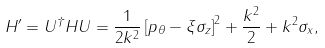<formula> <loc_0><loc_0><loc_500><loc_500>H ^ { \prime } = U ^ { \dagger } H U = \frac { 1 } { 2 k ^ { 2 } } \left [ p _ { \theta } - \xi \sigma _ { z } \right ] ^ { 2 } + \frac { k ^ { 2 } } { 2 } + k ^ { 2 } \sigma _ { x } ,</formula> 